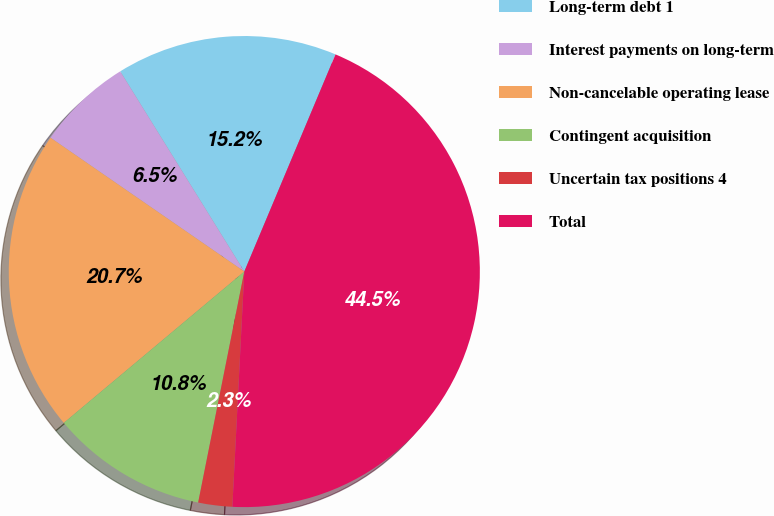Convert chart. <chart><loc_0><loc_0><loc_500><loc_500><pie_chart><fcel>Long-term debt 1<fcel>Interest payments on long-term<fcel>Non-cancelable operating lease<fcel>Contingent acquisition<fcel>Uncertain tax positions 4<fcel>Total<nl><fcel>15.16%<fcel>6.55%<fcel>20.72%<fcel>10.76%<fcel>2.33%<fcel>44.48%<nl></chart> 